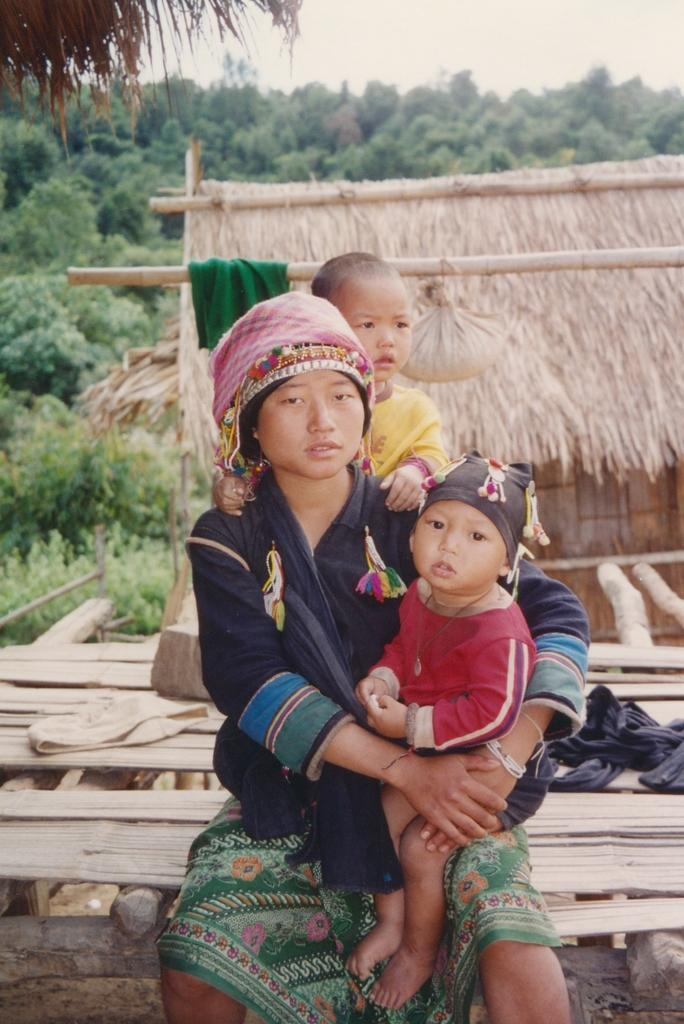How many people are in the image? There are three persons in the image. Where are the persons located? The persons are on a wooden bed. What can be seen in the background of the image? There is a hurt, trees, and the sky visible in the background of the image. What time of day does the image appear to be taken? The image appears to be taken during the day. Can you see any potatoes in the image? There are no potatoes present in the image. What type of wind, zephyr, can be seen in the image? There is no wind or zephyr visible in the image; it is a still scene. 